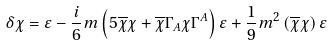<formula> <loc_0><loc_0><loc_500><loc_500>\delta \chi = \varepsilon - \frac { i } { 6 } m \left ( 5 \overline { \chi } \chi + \overline { \chi } \Gamma _ { A } \chi \Gamma ^ { A } \right ) \varepsilon + \frac { 1 } { 9 } m ^ { 2 } \left ( \overline { \chi } \chi \right ) \varepsilon</formula> 